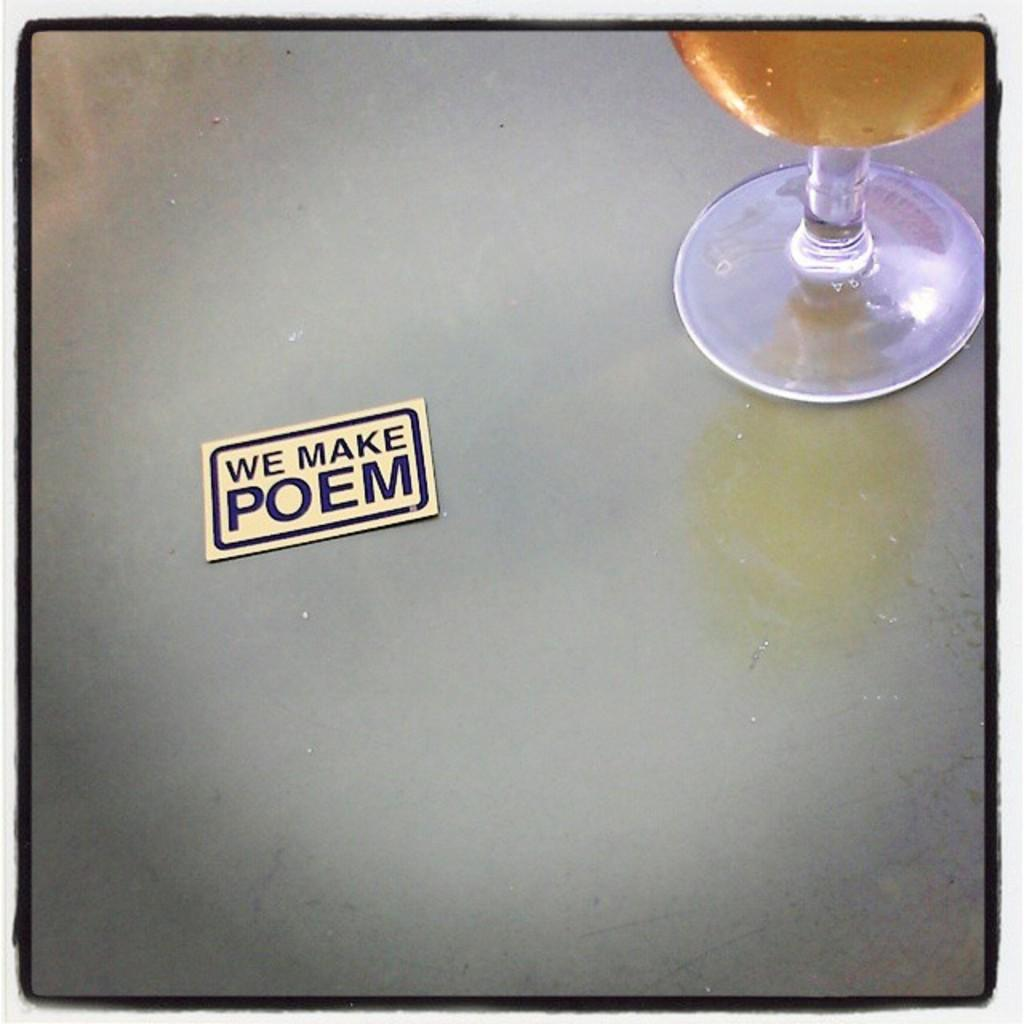<image>
Summarize the visual content of the image. A glass of alochol with a sticker beside it saying we make poem. 